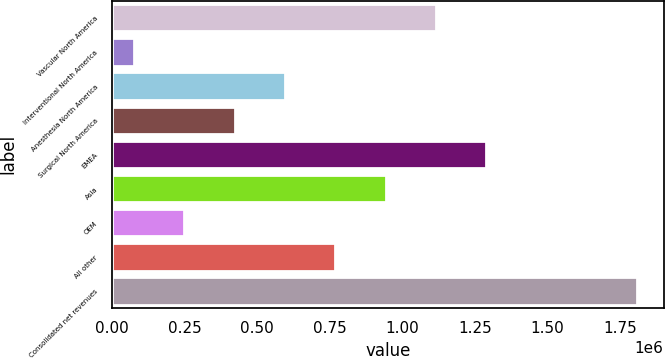<chart> <loc_0><loc_0><loc_500><loc_500><bar_chart><fcel>Vascular North America<fcel>Interventional North America<fcel>Anesthesia North America<fcel>Surgical North America<fcel>EMEA<fcel>Asia<fcel>OEM<fcel>All other<fcel>Consolidated net revenues<nl><fcel>1.11589e+06<fcel>75196<fcel>595544<fcel>422095<fcel>1.28934e+06<fcel>942443<fcel>248645<fcel>768994<fcel>1.80969e+06<nl></chart> 